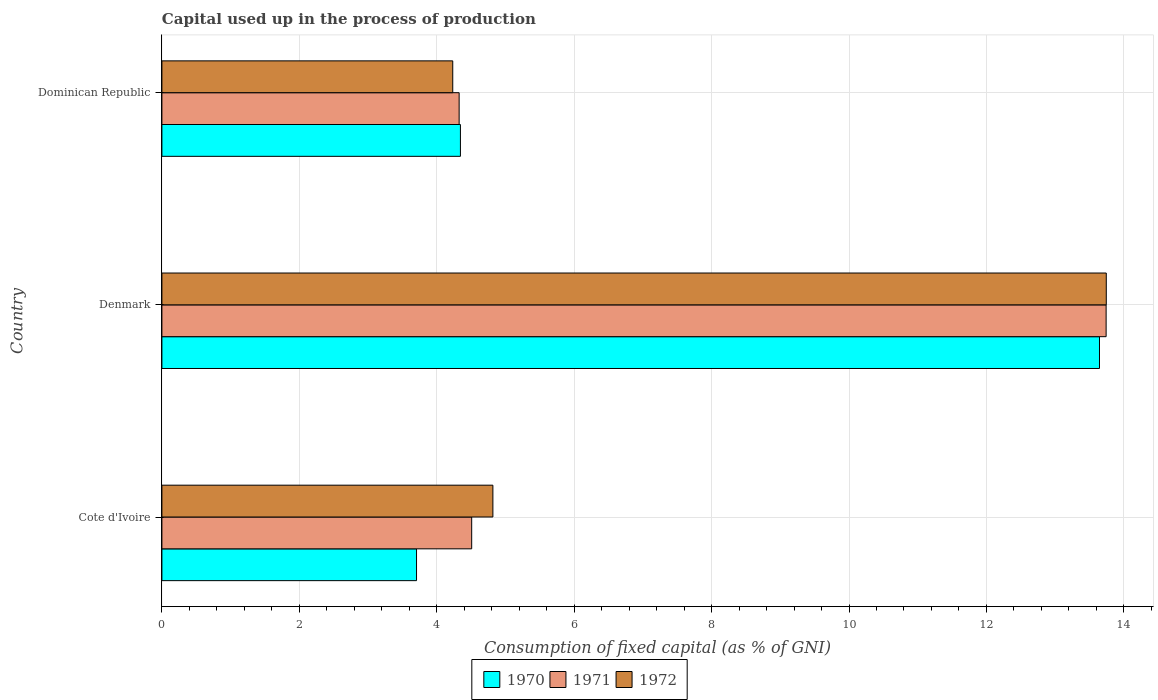How many different coloured bars are there?
Give a very brief answer. 3. In how many cases, is the number of bars for a given country not equal to the number of legend labels?
Provide a short and direct response. 0. What is the capital used up in the process of production in 1970 in Denmark?
Your answer should be compact. 13.65. Across all countries, what is the maximum capital used up in the process of production in 1972?
Give a very brief answer. 13.74. Across all countries, what is the minimum capital used up in the process of production in 1970?
Keep it short and to the point. 3.71. In which country was the capital used up in the process of production in 1972 maximum?
Your answer should be very brief. Denmark. In which country was the capital used up in the process of production in 1970 minimum?
Provide a short and direct response. Cote d'Ivoire. What is the total capital used up in the process of production in 1970 in the graph?
Provide a short and direct response. 21.7. What is the difference between the capital used up in the process of production in 1971 in Cote d'Ivoire and that in Dominican Republic?
Provide a short and direct response. 0.18. What is the difference between the capital used up in the process of production in 1972 in Cote d'Ivoire and the capital used up in the process of production in 1970 in Dominican Republic?
Offer a terse response. 0.47. What is the average capital used up in the process of production in 1972 per country?
Your answer should be compact. 7.6. What is the difference between the capital used up in the process of production in 1970 and capital used up in the process of production in 1972 in Cote d'Ivoire?
Give a very brief answer. -1.11. In how many countries, is the capital used up in the process of production in 1971 greater than 6.4 %?
Your response must be concise. 1. What is the ratio of the capital used up in the process of production in 1970 in Denmark to that in Dominican Republic?
Give a very brief answer. 3.14. Is the capital used up in the process of production in 1972 in Cote d'Ivoire less than that in Dominican Republic?
Keep it short and to the point. No. Is the difference between the capital used up in the process of production in 1970 in Cote d'Ivoire and Denmark greater than the difference between the capital used up in the process of production in 1972 in Cote d'Ivoire and Denmark?
Provide a short and direct response. No. What is the difference between the highest and the second highest capital used up in the process of production in 1970?
Provide a short and direct response. 9.3. What is the difference between the highest and the lowest capital used up in the process of production in 1971?
Provide a short and direct response. 9.42. In how many countries, is the capital used up in the process of production in 1972 greater than the average capital used up in the process of production in 1972 taken over all countries?
Provide a succinct answer. 1. What does the 1st bar from the top in Denmark represents?
Give a very brief answer. 1972. What does the 3rd bar from the bottom in Cote d'Ivoire represents?
Give a very brief answer. 1972. Is it the case that in every country, the sum of the capital used up in the process of production in 1971 and capital used up in the process of production in 1972 is greater than the capital used up in the process of production in 1970?
Keep it short and to the point. Yes. How many bars are there?
Your answer should be very brief. 9. Are the values on the major ticks of X-axis written in scientific E-notation?
Give a very brief answer. No. Does the graph contain any zero values?
Ensure brevity in your answer.  No. Does the graph contain grids?
Offer a terse response. Yes. Where does the legend appear in the graph?
Provide a short and direct response. Bottom center. How many legend labels are there?
Ensure brevity in your answer.  3. What is the title of the graph?
Your answer should be very brief. Capital used up in the process of production. What is the label or title of the X-axis?
Keep it short and to the point. Consumption of fixed capital (as % of GNI). What is the Consumption of fixed capital (as % of GNI) in 1970 in Cote d'Ivoire?
Your answer should be very brief. 3.71. What is the Consumption of fixed capital (as % of GNI) in 1971 in Cote d'Ivoire?
Ensure brevity in your answer.  4.51. What is the Consumption of fixed capital (as % of GNI) in 1972 in Cote d'Ivoire?
Your response must be concise. 4.82. What is the Consumption of fixed capital (as % of GNI) of 1970 in Denmark?
Your response must be concise. 13.65. What is the Consumption of fixed capital (as % of GNI) in 1971 in Denmark?
Your answer should be very brief. 13.74. What is the Consumption of fixed capital (as % of GNI) of 1972 in Denmark?
Offer a very short reply. 13.74. What is the Consumption of fixed capital (as % of GNI) of 1970 in Dominican Republic?
Ensure brevity in your answer.  4.34. What is the Consumption of fixed capital (as % of GNI) of 1971 in Dominican Republic?
Offer a very short reply. 4.33. What is the Consumption of fixed capital (as % of GNI) of 1972 in Dominican Republic?
Provide a short and direct response. 4.23. Across all countries, what is the maximum Consumption of fixed capital (as % of GNI) of 1970?
Your answer should be very brief. 13.65. Across all countries, what is the maximum Consumption of fixed capital (as % of GNI) of 1971?
Your response must be concise. 13.74. Across all countries, what is the maximum Consumption of fixed capital (as % of GNI) of 1972?
Your response must be concise. 13.74. Across all countries, what is the minimum Consumption of fixed capital (as % of GNI) of 1970?
Your response must be concise. 3.71. Across all countries, what is the minimum Consumption of fixed capital (as % of GNI) in 1971?
Offer a very short reply. 4.33. Across all countries, what is the minimum Consumption of fixed capital (as % of GNI) of 1972?
Give a very brief answer. 4.23. What is the total Consumption of fixed capital (as % of GNI) of 1970 in the graph?
Keep it short and to the point. 21.7. What is the total Consumption of fixed capital (as % of GNI) in 1971 in the graph?
Offer a very short reply. 22.58. What is the total Consumption of fixed capital (as % of GNI) in 1972 in the graph?
Offer a terse response. 22.79. What is the difference between the Consumption of fixed capital (as % of GNI) in 1970 in Cote d'Ivoire and that in Denmark?
Make the answer very short. -9.94. What is the difference between the Consumption of fixed capital (as % of GNI) in 1971 in Cote d'Ivoire and that in Denmark?
Offer a very short reply. -9.23. What is the difference between the Consumption of fixed capital (as % of GNI) in 1972 in Cote d'Ivoire and that in Denmark?
Provide a short and direct response. -8.93. What is the difference between the Consumption of fixed capital (as % of GNI) in 1970 in Cote d'Ivoire and that in Dominican Republic?
Give a very brief answer. -0.64. What is the difference between the Consumption of fixed capital (as % of GNI) of 1971 in Cote d'Ivoire and that in Dominican Republic?
Provide a succinct answer. 0.18. What is the difference between the Consumption of fixed capital (as % of GNI) of 1972 in Cote d'Ivoire and that in Dominican Republic?
Your answer should be compact. 0.58. What is the difference between the Consumption of fixed capital (as % of GNI) in 1970 in Denmark and that in Dominican Republic?
Ensure brevity in your answer.  9.3. What is the difference between the Consumption of fixed capital (as % of GNI) of 1971 in Denmark and that in Dominican Republic?
Make the answer very short. 9.42. What is the difference between the Consumption of fixed capital (as % of GNI) in 1972 in Denmark and that in Dominican Republic?
Your response must be concise. 9.51. What is the difference between the Consumption of fixed capital (as % of GNI) in 1970 in Cote d'Ivoire and the Consumption of fixed capital (as % of GNI) in 1971 in Denmark?
Give a very brief answer. -10.04. What is the difference between the Consumption of fixed capital (as % of GNI) of 1970 in Cote d'Ivoire and the Consumption of fixed capital (as % of GNI) of 1972 in Denmark?
Your response must be concise. -10.04. What is the difference between the Consumption of fixed capital (as % of GNI) of 1971 in Cote d'Ivoire and the Consumption of fixed capital (as % of GNI) of 1972 in Denmark?
Your answer should be very brief. -9.24. What is the difference between the Consumption of fixed capital (as % of GNI) in 1970 in Cote d'Ivoire and the Consumption of fixed capital (as % of GNI) in 1971 in Dominican Republic?
Ensure brevity in your answer.  -0.62. What is the difference between the Consumption of fixed capital (as % of GNI) of 1970 in Cote d'Ivoire and the Consumption of fixed capital (as % of GNI) of 1972 in Dominican Republic?
Give a very brief answer. -0.53. What is the difference between the Consumption of fixed capital (as % of GNI) in 1971 in Cote d'Ivoire and the Consumption of fixed capital (as % of GNI) in 1972 in Dominican Republic?
Offer a terse response. 0.28. What is the difference between the Consumption of fixed capital (as % of GNI) of 1970 in Denmark and the Consumption of fixed capital (as % of GNI) of 1971 in Dominican Republic?
Your answer should be very brief. 9.32. What is the difference between the Consumption of fixed capital (as % of GNI) of 1970 in Denmark and the Consumption of fixed capital (as % of GNI) of 1972 in Dominican Republic?
Offer a terse response. 9.41. What is the difference between the Consumption of fixed capital (as % of GNI) in 1971 in Denmark and the Consumption of fixed capital (as % of GNI) in 1972 in Dominican Republic?
Provide a short and direct response. 9.51. What is the average Consumption of fixed capital (as % of GNI) in 1970 per country?
Your answer should be compact. 7.23. What is the average Consumption of fixed capital (as % of GNI) of 1971 per country?
Your answer should be compact. 7.53. What is the average Consumption of fixed capital (as % of GNI) in 1972 per country?
Your answer should be compact. 7.6. What is the difference between the Consumption of fixed capital (as % of GNI) of 1970 and Consumption of fixed capital (as % of GNI) of 1971 in Cote d'Ivoire?
Your answer should be very brief. -0.8. What is the difference between the Consumption of fixed capital (as % of GNI) of 1970 and Consumption of fixed capital (as % of GNI) of 1972 in Cote d'Ivoire?
Your answer should be compact. -1.11. What is the difference between the Consumption of fixed capital (as % of GNI) of 1971 and Consumption of fixed capital (as % of GNI) of 1972 in Cote d'Ivoire?
Make the answer very short. -0.31. What is the difference between the Consumption of fixed capital (as % of GNI) of 1970 and Consumption of fixed capital (as % of GNI) of 1971 in Denmark?
Offer a terse response. -0.1. What is the difference between the Consumption of fixed capital (as % of GNI) of 1970 and Consumption of fixed capital (as % of GNI) of 1972 in Denmark?
Make the answer very short. -0.1. What is the difference between the Consumption of fixed capital (as % of GNI) in 1971 and Consumption of fixed capital (as % of GNI) in 1972 in Denmark?
Provide a succinct answer. -0. What is the difference between the Consumption of fixed capital (as % of GNI) of 1970 and Consumption of fixed capital (as % of GNI) of 1971 in Dominican Republic?
Ensure brevity in your answer.  0.02. What is the difference between the Consumption of fixed capital (as % of GNI) of 1970 and Consumption of fixed capital (as % of GNI) of 1972 in Dominican Republic?
Your answer should be compact. 0.11. What is the difference between the Consumption of fixed capital (as % of GNI) of 1971 and Consumption of fixed capital (as % of GNI) of 1972 in Dominican Republic?
Your response must be concise. 0.09. What is the ratio of the Consumption of fixed capital (as % of GNI) in 1970 in Cote d'Ivoire to that in Denmark?
Keep it short and to the point. 0.27. What is the ratio of the Consumption of fixed capital (as % of GNI) in 1971 in Cote d'Ivoire to that in Denmark?
Offer a very short reply. 0.33. What is the ratio of the Consumption of fixed capital (as % of GNI) in 1972 in Cote d'Ivoire to that in Denmark?
Make the answer very short. 0.35. What is the ratio of the Consumption of fixed capital (as % of GNI) in 1970 in Cote d'Ivoire to that in Dominican Republic?
Provide a short and direct response. 0.85. What is the ratio of the Consumption of fixed capital (as % of GNI) of 1971 in Cote d'Ivoire to that in Dominican Republic?
Provide a short and direct response. 1.04. What is the ratio of the Consumption of fixed capital (as % of GNI) in 1972 in Cote d'Ivoire to that in Dominican Republic?
Offer a very short reply. 1.14. What is the ratio of the Consumption of fixed capital (as % of GNI) in 1970 in Denmark to that in Dominican Republic?
Your response must be concise. 3.14. What is the ratio of the Consumption of fixed capital (as % of GNI) of 1971 in Denmark to that in Dominican Republic?
Keep it short and to the point. 3.18. What is the ratio of the Consumption of fixed capital (as % of GNI) of 1972 in Denmark to that in Dominican Republic?
Offer a very short reply. 3.25. What is the difference between the highest and the second highest Consumption of fixed capital (as % of GNI) in 1970?
Offer a terse response. 9.3. What is the difference between the highest and the second highest Consumption of fixed capital (as % of GNI) of 1971?
Make the answer very short. 9.23. What is the difference between the highest and the second highest Consumption of fixed capital (as % of GNI) in 1972?
Ensure brevity in your answer.  8.93. What is the difference between the highest and the lowest Consumption of fixed capital (as % of GNI) of 1970?
Keep it short and to the point. 9.94. What is the difference between the highest and the lowest Consumption of fixed capital (as % of GNI) in 1971?
Ensure brevity in your answer.  9.42. What is the difference between the highest and the lowest Consumption of fixed capital (as % of GNI) of 1972?
Your answer should be compact. 9.51. 